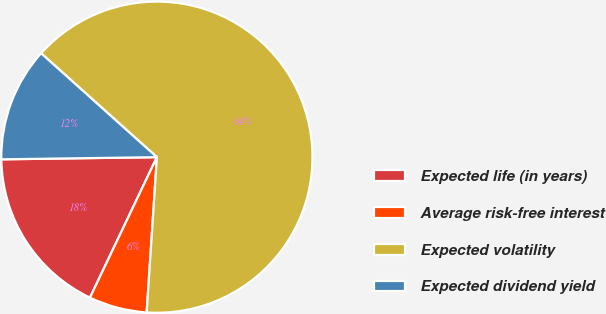Convert chart to OTSL. <chart><loc_0><loc_0><loc_500><loc_500><pie_chart><fcel>Expected life (in years)<fcel>Average risk-free interest<fcel>Expected volatility<fcel>Expected dividend yield<nl><fcel>17.7%<fcel>6.03%<fcel>64.41%<fcel>11.86%<nl></chart> 